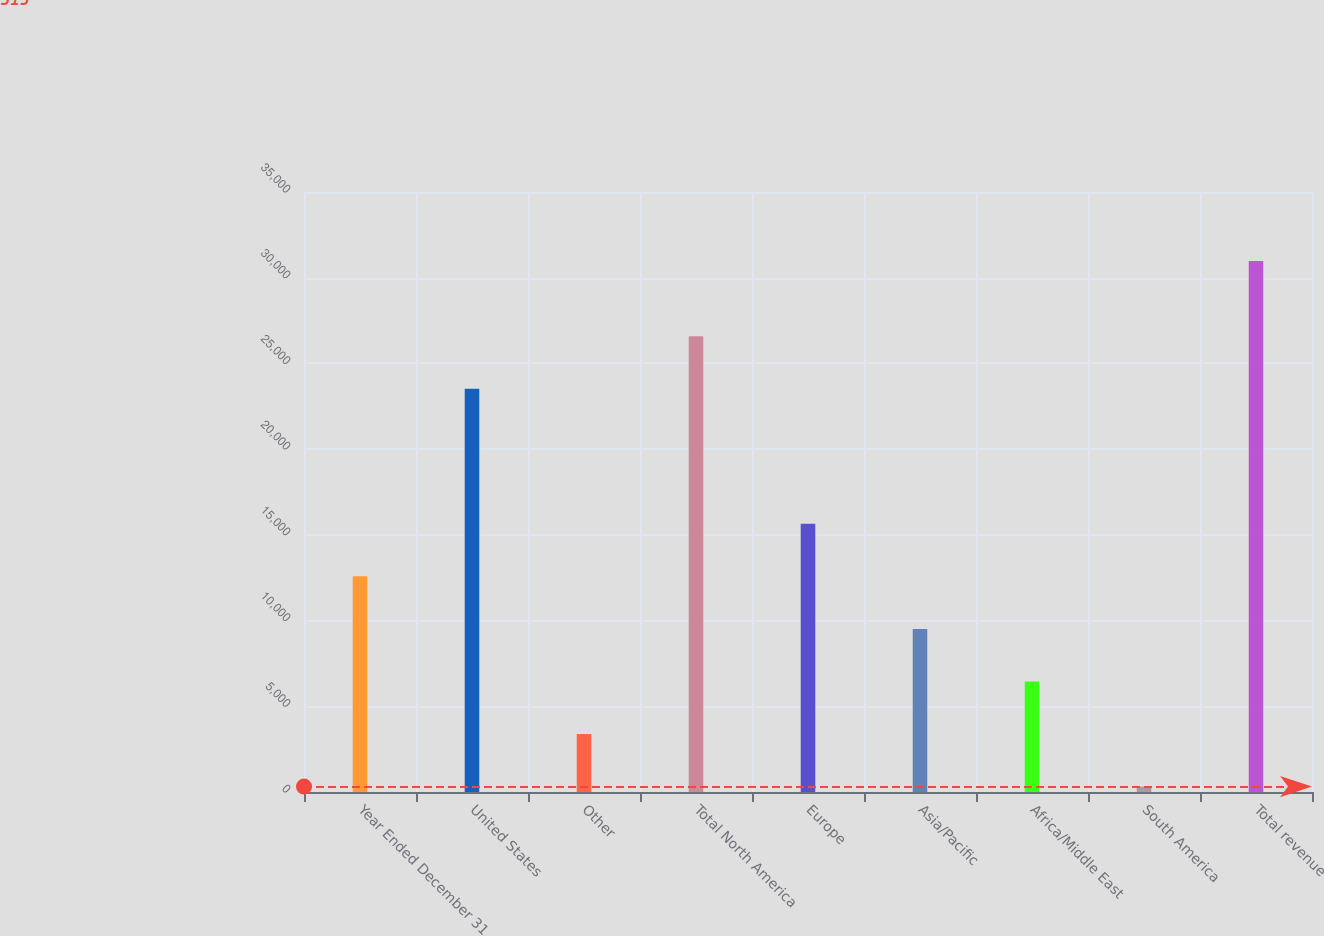Convert chart. <chart><loc_0><loc_0><loc_500><loc_500><bar_chart><fcel>Year Ended December 31<fcel>United States<fcel>Other<fcel>Total North America<fcel>Europe<fcel>Asia/Pacific<fcel>Africa/Middle East<fcel>South America<fcel>Total revenue<nl><fcel>12578.2<fcel>23519<fcel>3380.8<fcel>26584.8<fcel>15644<fcel>9512.4<fcel>6446.6<fcel>315<fcel>30973<nl></chart> 